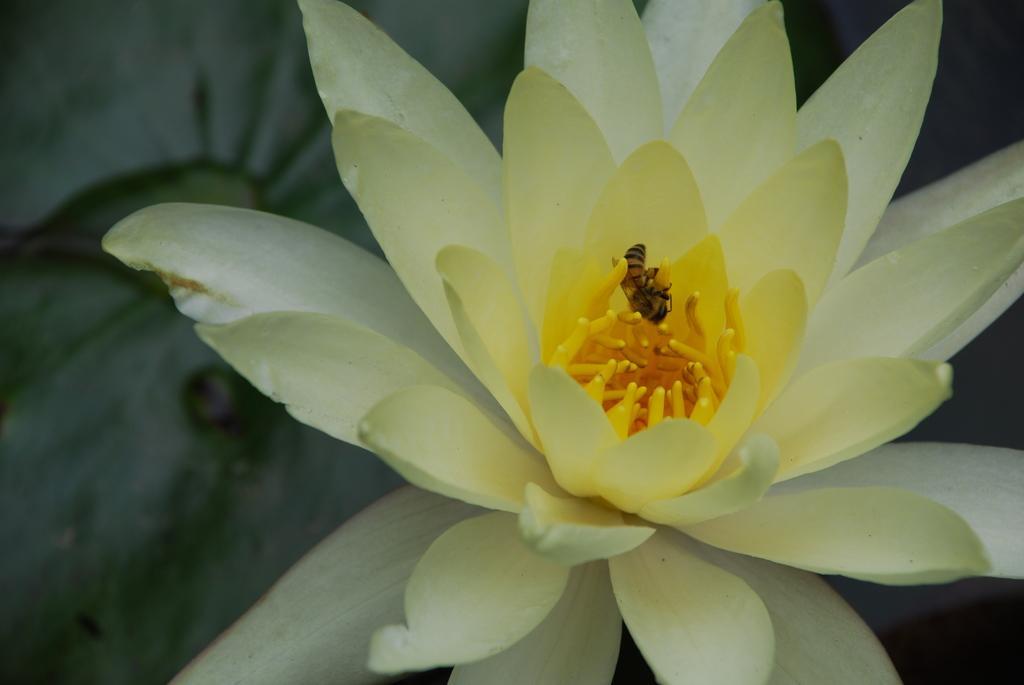In one or two sentences, can you explain what this image depicts? In this picture there is a flower which is in light green in color and there is a yellow color in middle of it and there is a insect above it. 